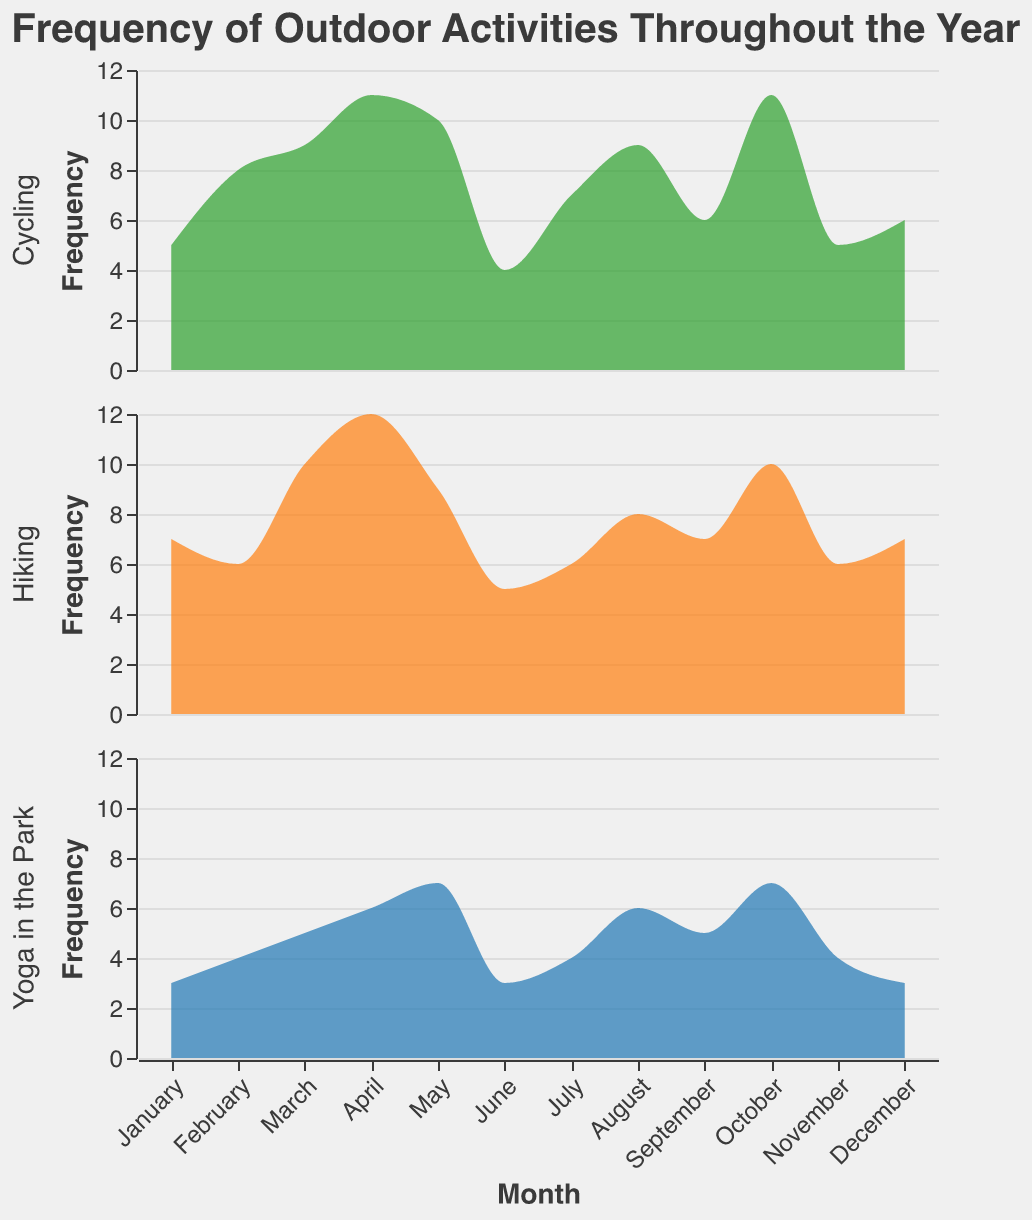What outdoor activity had the highest frequency in April? By looking at the frequency values for each activity in April, we can see that Hiking (12), Cycling (11), and Yoga in the Park (6). Hence, Hiking had the highest frequency.
Answer: Hiking In which month was "Yoga in the Park" chosen more frequently than "Cycling"? By comparing the frequency of "Yoga in the Park" and "Cycling" across all months, we see that in May, Yoga in the Park had a frequency of 7 while Cycling had a frequency of 10. So, this did not happen in any month.
Answer: No month What was the total frequency of all outdoor activities in October? By summing the frequencies for Hiking (10), Cycling (11), and Yoga in the Park (7) in October, we get 10 + 11 + 7 = 28.
Answer: 28 Which month had the lowest total frequency for "Hiking"? By comparing the frequency values for Hiking in each month, we find that June had the lowest frequency of 5.
Answer: June How does the frequency of "Cycling" compare to "Hiking" in February? In February, the frequency of Cycling (8) is greater than that of Hiking (6).
Answer: Cycling is greater What is the trend of "Hiking" frequency from January to December? By examining the frequencies of Hiking from January to December, we observe the values: 7, 6, 10, 12, 9, 5, 6, 8, 7, 10, 6, 7. The trend appears to be variable with peaks in April and October and a trough in June.
Answer: Variable with peaks in April and October Which month has the highest combined frequency for all activities combined? Summing the frequencies for all activities for each month, October has the highest combined frequency with a total of 10 (Hiking) + 11 (Cycling) + 7 (Yoga in the Park) = 28.
Answer: October What is the average frequency of "Cycling" over the entire year? Adding the monthly frequencies for Cycling: 5, 8, 9, 11, 10, 4, 7, 9, 6, 11, 5, 6, gives a total of 91. Dividing by the number of months (12), the average frequency is 91/12 ≈ 7.58.
Answer: 7.58 How does the popularity of "Hiking" change from summer (June-August) to fall (September-November)? Summing the frequencies for Hiking in summer (5 + 6 + 8 = 19) and fall (7 + 10 + 6 = 23) shows an increase in popularity from 19 in summer to 23 in fall.
Answer: Increases 